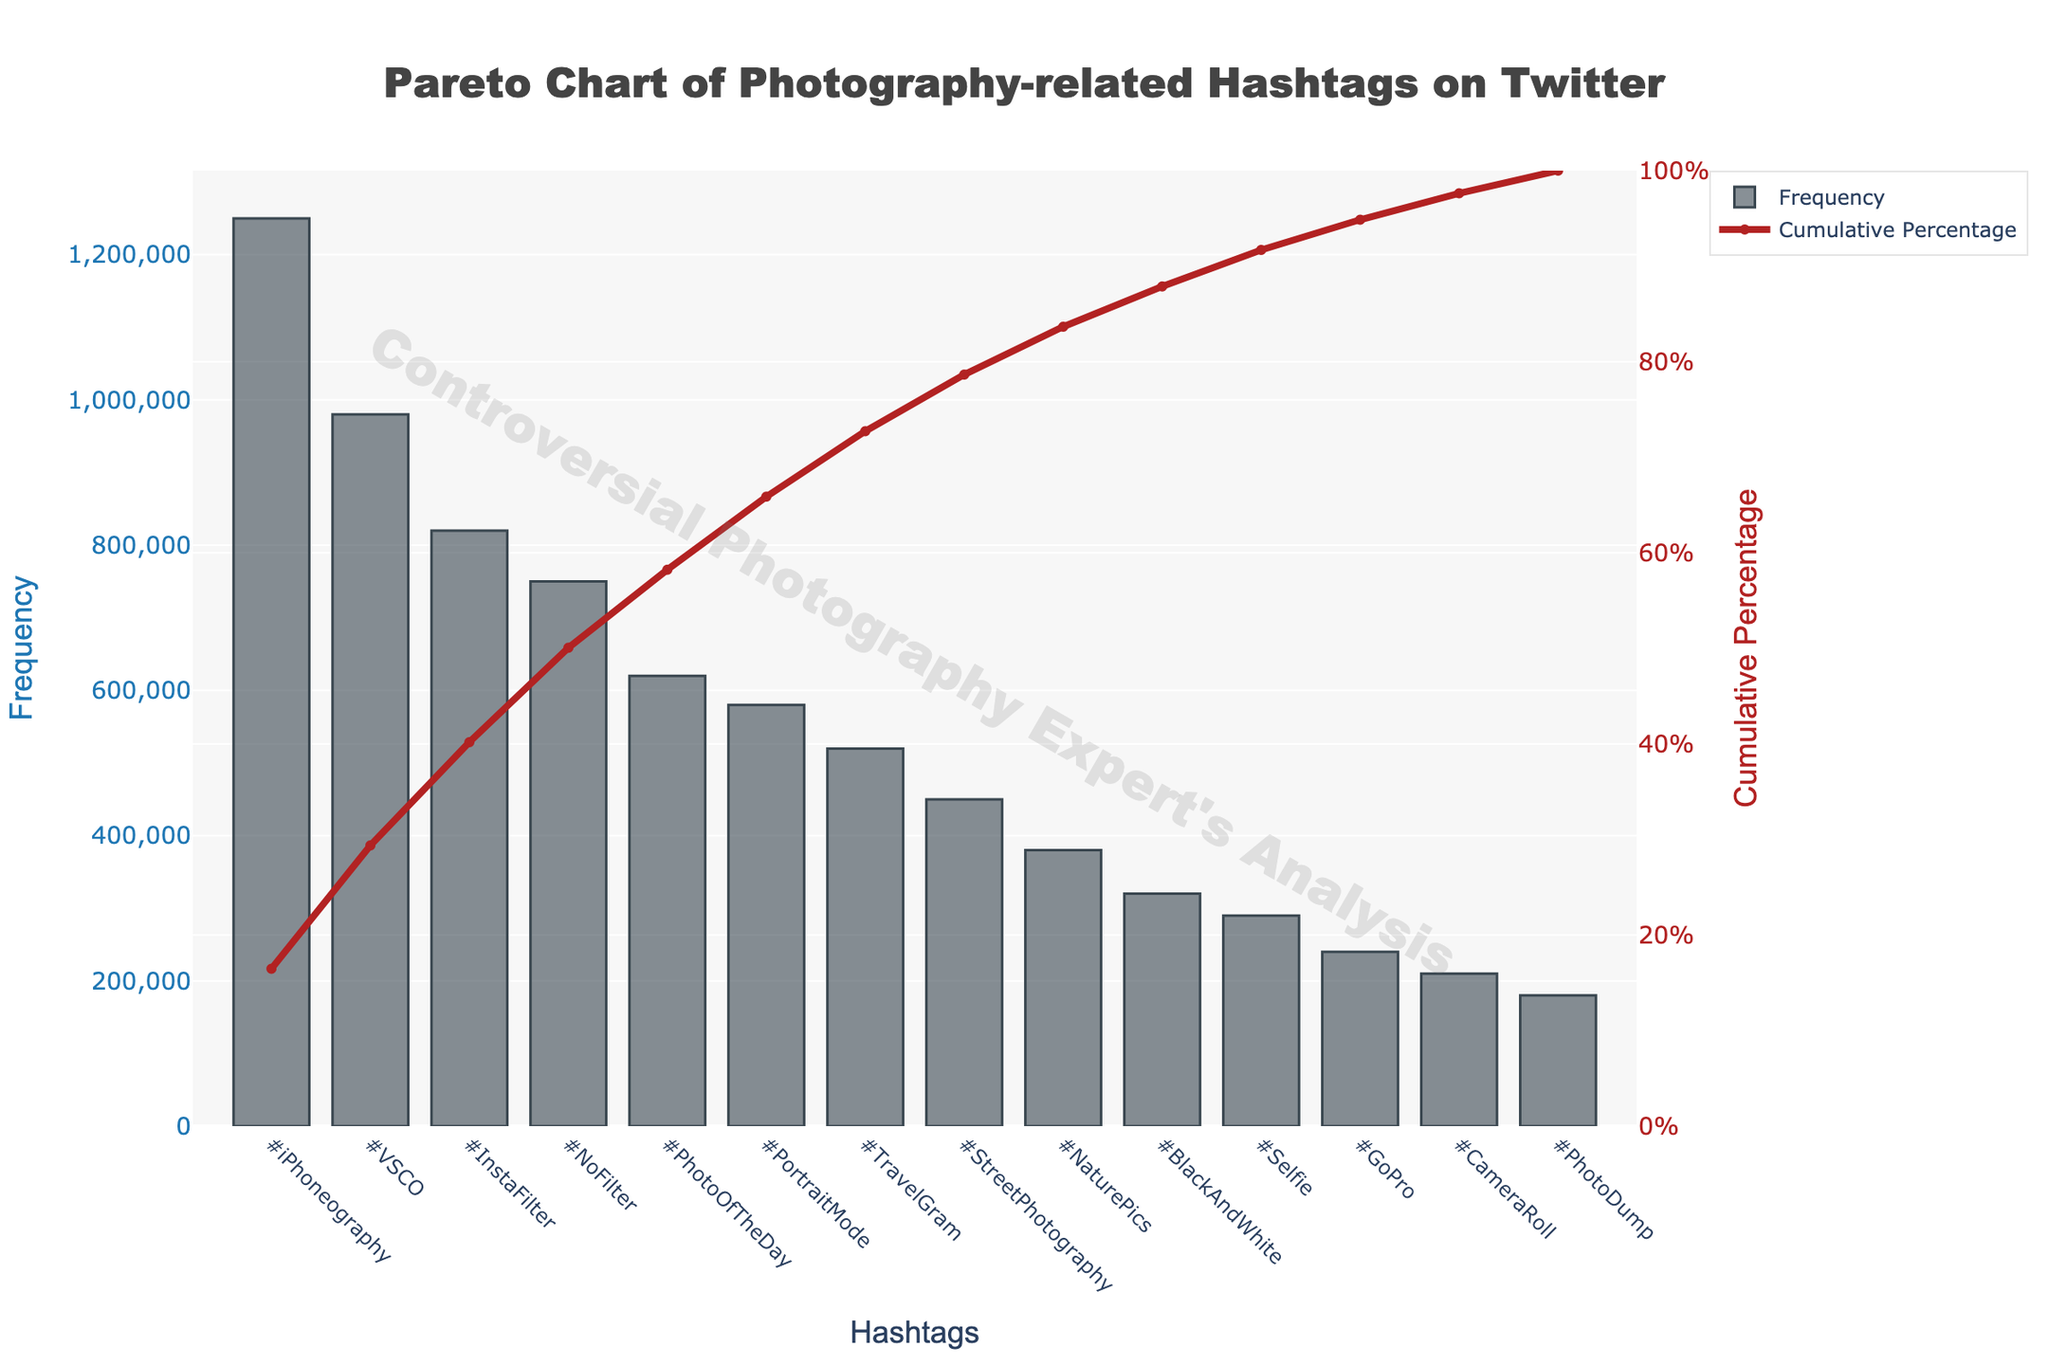What's the title of the figure? The title of the figure is prominently displayed at the top of the plot.
Answer: Pareto Chart of Photography-related Hashtags on Twitter Which hashtag has the highest frequency of use? By observing the height of the bars in the chart, the highest bar represents the most frequently used hashtag.
Answer: #iPhoneography What is the cumulative percentage for the hashtag #InstaFilter? Locate the hashtag #InstaFilter, then trace the corresponding point on the cumulative percentage line (right y-axis).
Answer: Approximately 54% How many hashtags are included in this figure? Count the number of unique bars (or points on the x-axis) representing different hashtags.
Answer: 14 What is the color of the bars representing the frequency? Look at the color fill of the bars on the left y-axis.
Answer: A shade of grey Between which two hashtags does the cumulative percentage reach 50%? Examine the cumulative percentage line and identify where it crosses the 50% mark, then see which hashtags lie around this transition.
Answer: Between #InstaFilter and #NoFilter How does the frequency of #TravelGram compare to #PortraitMode? Measure the height of the bars corresponding to both hashtags to compare their frequencies.
Answer: #TravelGram has a lower frequency than #PortraitMode What frequency range is covered by the left y-axis? Check the minimum and maximum values on the left y-axis which represents frequency.
Answer: 0 to 1,250,000 Which three hashtags contribute to approximately the top 65% of the cumulative frequency? Follow the cumulative percentage line to 65% and then identify the hashtags from the start up to this point.
Answer: #iPhoneography, #VSCO, #InstaFilter What is the cumulative percentage after the first five hashtags? Sum up the cumulative percentages corresponding to the first five hashtags from left to right.
Answer: Approximately 79% 